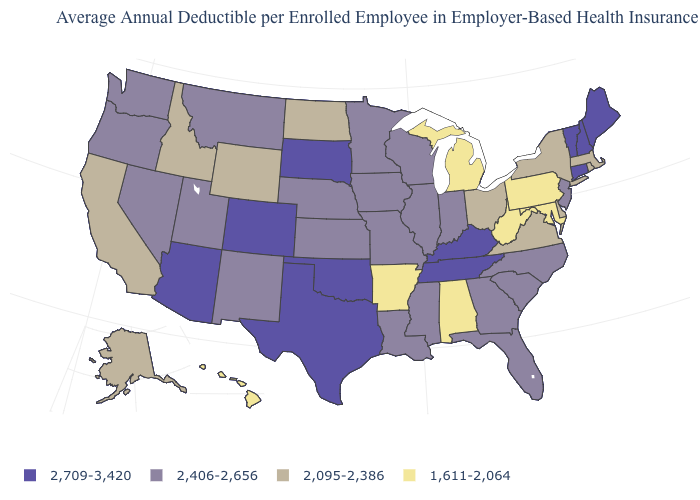Name the states that have a value in the range 1,611-2,064?
Be succinct. Alabama, Arkansas, Hawaii, Maryland, Michigan, Pennsylvania, West Virginia. Name the states that have a value in the range 1,611-2,064?
Short answer required. Alabama, Arkansas, Hawaii, Maryland, Michigan, Pennsylvania, West Virginia. What is the highest value in the USA?
Short answer required. 2,709-3,420. What is the value of Texas?
Write a very short answer. 2,709-3,420. What is the value of Iowa?
Quick response, please. 2,406-2,656. Among the states that border Illinois , which have the lowest value?
Short answer required. Indiana, Iowa, Missouri, Wisconsin. Name the states that have a value in the range 2,709-3,420?
Keep it brief. Arizona, Colorado, Connecticut, Kentucky, Maine, New Hampshire, Oklahoma, South Dakota, Tennessee, Texas, Vermont. What is the value of Maine?
Concise answer only. 2,709-3,420. Name the states that have a value in the range 2,709-3,420?
Give a very brief answer. Arizona, Colorado, Connecticut, Kentucky, Maine, New Hampshire, Oklahoma, South Dakota, Tennessee, Texas, Vermont. Which states hav the highest value in the MidWest?
Write a very short answer. South Dakota. Name the states that have a value in the range 1,611-2,064?
Quick response, please. Alabama, Arkansas, Hawaii, Maryland, Michigan, Pennsylvania, West Virginia. Name the states that have a value in the range 2,095-2,386?
Keep it brief. Alaska, California, Delaware, Idaho, Massachusetts, New York, North Dakota, Ohio, Rhode Island, Virginia, Wyoming. Does North Carolina have the same value as Arkansas?
Short answer required. No. Which states have the highest value in the USA?
Short answer required. Arizona, Colorado, Connecticut, Kentucky, Maine, New Hampshire, Oklahoma, South Dakota, Tennessee, Texas, Vermont. Name the states that have a value in the range 2,406-2,656?
Quick response, please. Florida, Georgia, Illinois, Indiana, Iowa, Kansas, Louisiana, Minnesota, Mississippi, Missouri, Montana, Nebraska, Nevada, New Jersey, New Mexico, North Carolina, Oregon, South Carolina, Utah, Washington, Wisconsin. 